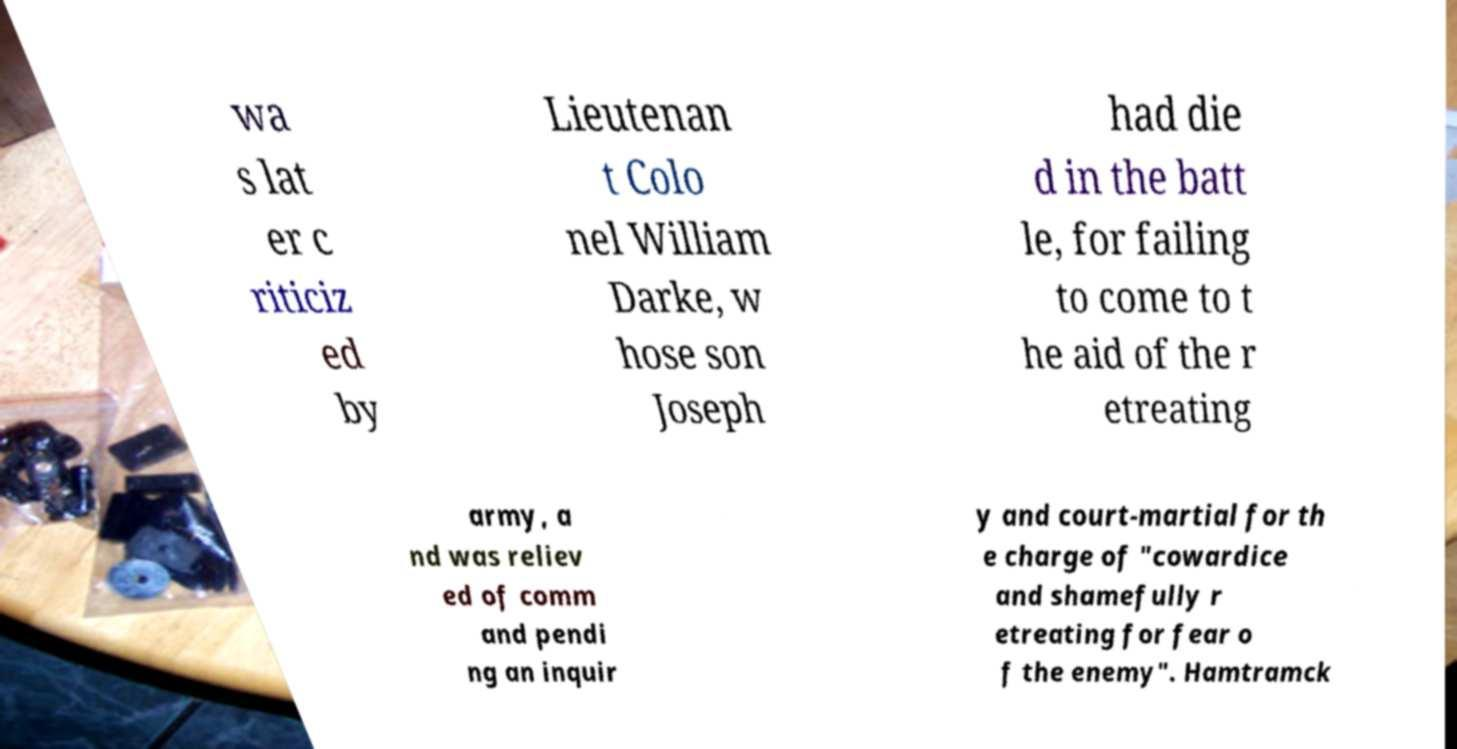Please read and relay the text visible in this image. What does it say? wa s lat er c riticiz ed by Lieutenan t Colo nel William Darke, w hose son Joseph had die d in the batt le, for failing to come to t he aid of the r etreating army, a nd was reliev ed of comm and pendi ng an inquir y and court-martial for th e charge of "cowardice and shamefully r etreating for fear o f the enemy". Hamtramck 